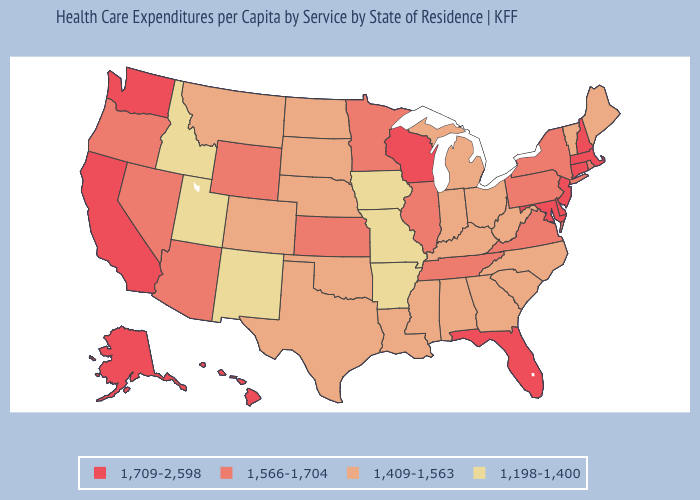Among the states that border Iowa , which have the lowest value?
Answer briefly. Missouri. Does Maryland have a higher value than Nebraska?
Concise answer only. Yes. What is the value of Missouri?
Be succinct. 1,198-1,400. Which states hav the highest value in the MidWest?
Be succinct. Wisconsin. Does the map have missing data?
Keep it brief. No. What is the lowest value in states that border Utah?
Quick response, please. 1,198-1,400. What is the value of New Jersey?
Be succinct. 1,709-2,598. What is the lowest value in the Northeast?
Answer briefly. 1,409-1,563. What is the value of Washington?
Be succinct. 1,709-2,598. Does Georgia have the lowest value in the USA?
Short answer required. No. Which states have the lowest value in the South?
Write a very short answer. Arkansas. What is the value of Rhode Island?
Short answer required. 1,566-1,704. What is the value of North Dakota?
Be succinct. 1,409-1,563. Among the states that border Texas , which have the highest value?
Write a very short answer. Louisiana, Oklahoma. 